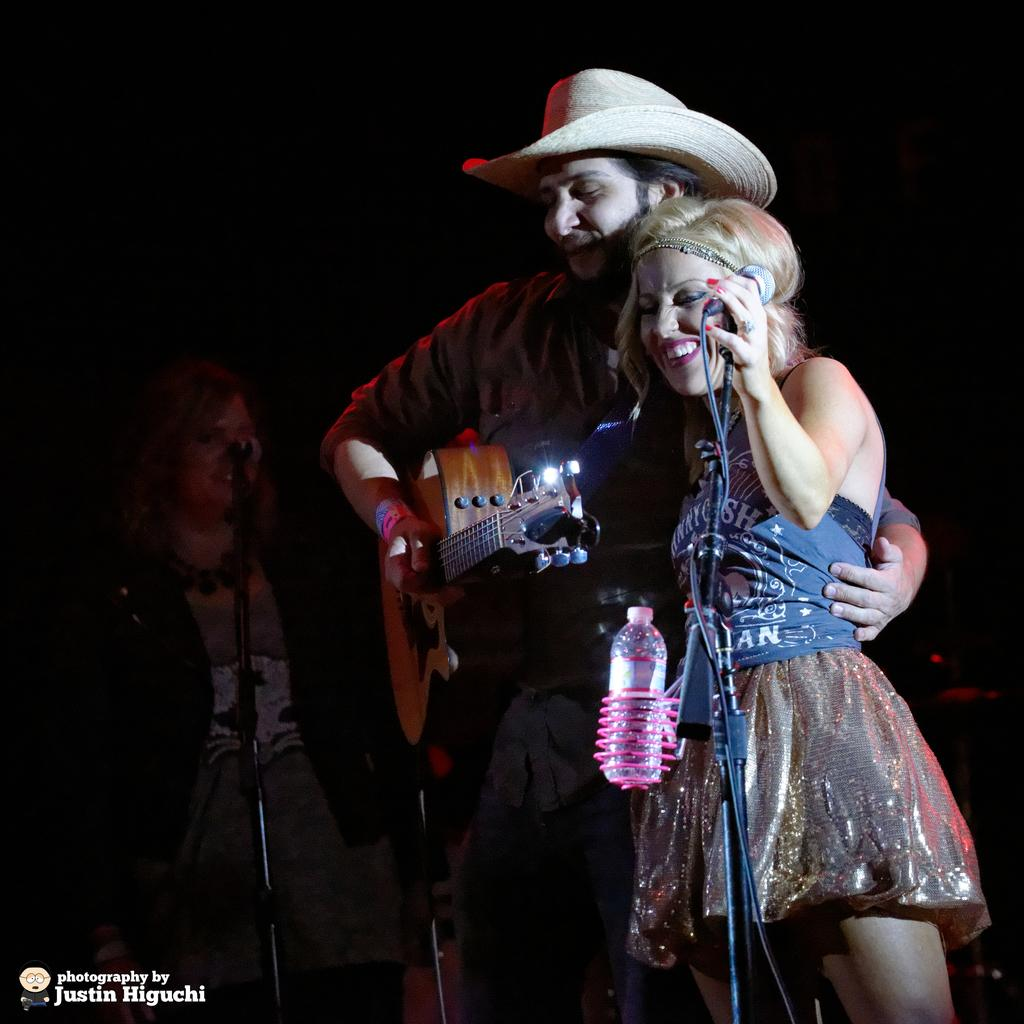How many people are in the image? There are three persons in the image. What are the people in the image doing? The three persons are standing and smiling. Can you describe what one of the persons is holding? One person is holding a guitar. What is the person holding the guitar wearing? The person holding the guitar is wearing a hat. What is another person holding in the image? Another person is holding a microphone. Can you describe any other objects in the image related to the microphone? There are microphones with stands in the image. What type of disgust can be seen on the faces of the men in the image? There are no men in the image, and no one is displaying disgust. 